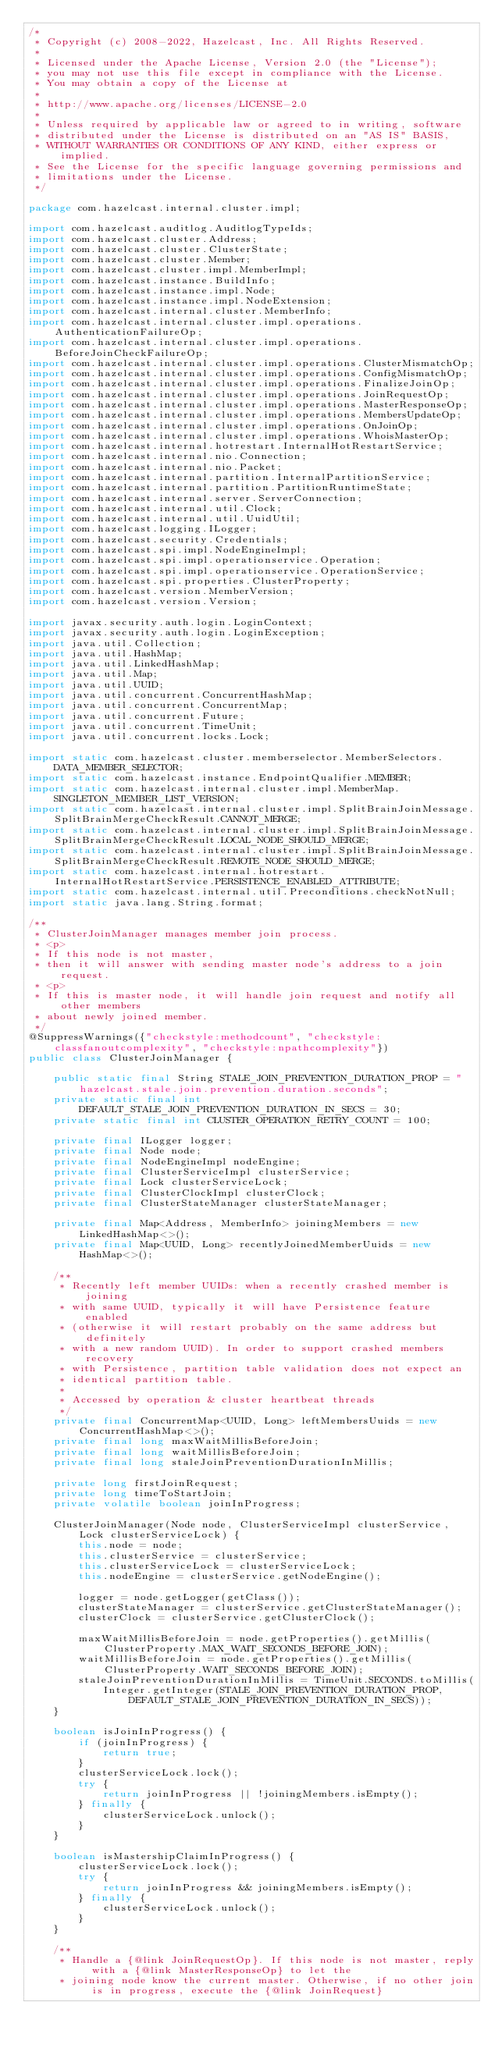Convert code to text. <code><loc_0><loc_0><loc_500><loc_500><_Java_>/*
 * Copyright (c) 2008-2022, Hazelcast, Inc. All Rights Reserved.
 *
 * Licensed under the Apache License, Version 2.0 (the "License");
 * you may not use this file except in compliance with the License.
 * You may obtain a copy of the License at
 *
 * http://www.apache.org/licenses/LICENSE-2.0
 *
 * Unless required by applicable law or agreed to in writing, software
 * distributed under the License is distributed on an "AS IS" BASIS,
 * WITHOUT WARRANTIES OR CONDITIONS OF ANY KIND, either express or implied.
 * See the License for the specific language governing permissions and
 * limitations under the License.
 */

package com.hazelcast.internal.cluster.impl;

import com.hazelcast.auditlog.AuditlogTypeIds;
import com.hazelcast.cluster.Address;
import com.hazelcast.cluster.ClusterState;
import com.hazelcast.cluster.Member;
import com.hazelcast.cluster.impl.MemberImpl;
import com.hazelcast.instance.BuildInfo;
import com.hazelcast.instance.impl.Node;
import com.hazelcast.instance.impl.NodeExtension;
import com.hazelcast.internal.cluster.MemberInfo;
import com.hazelcast.internal.cluster.impl.operations.AuthenticationFailureOp;
import com.hazelcast.internal.cluster.impl.operations.BeforeJoinCheckFailureOp;
import com.hazelcast.internal.cluster.impl.operations.ClusterMismatchOp;
import com.hazelcast.internal.cluster.impl.operations.ConfigMismatchOp;
import com.hazelcast.internal.cluster.impl.operations.FinalizeJoinOp;
import com.hazelcast.internal.cluster.impl.operations.JoinRequestOp;
import com.hazelcast.internal.cluster.impl.operations.MasterResponseOp;
import com.hazelcast.internal.cluster.impl.operations.MembersUpdateOp;
import com.hazelcast.internal.cluster.impl.operations.OnJoinOp;
import com.hazelcast.internal.cluster.impl.operations.WhoisMasterOp;
import com.hazelcast.internal.hotrestart.InternalHotRestartService;
import com.hazelcast.internal.nio.Connection;
import com.hazelcast.internal.nio.Packet;
import com.hazelcast.internal.partition.InternalPartitionService;
import com.hazelcast.internal.partition.PartitionRuntimeState;
import com.hazelcast.internal.server.ServerConnection;
import com.hazelcast.internal.util.Clock;
import com.hazelcast.internal.util.UuidUtil;
import com.hazelcast.logging.ILogger;
import com.hazelcast.security.Credentials;
import com.hazelcast.spi.impl.NodeEngineImpl;
import com.hazelcast.spi.impl.operationservice.Operation;
import com.hazelcast.spi.impl.operationservice.OperationService;
import com.hazelcast.spi.properties.ClusterProperty;
import com.hazelcast.version.MemberVersion;
import com.hazelcast.version.Version;

import javax.security.auth.login.LoginContext;
import javax.security.auth.login.LoginException;
import java.util.Collection;
import java.util.HashMap;
import java.util.LinkedHashMap;
import java.util.Map;
import java.util.UUID;
import java.util.concurrent.ConcurrentHashMap;
import java.util.concurrent.ConcurrentMap;
import java.util.concurrent.Future;
import java.util.concurrent.TimeUnit;
import java.util.concurrent.locks.Lock;

import static com.hazelcast.cluster.memberselector.MemberSelectors.DATA_MEMBER_SELECTOR;
import static com.hazelcast.instance.EndpointQualifier.MEMBER;
import static com.hazelcast.internal.cluster.impl.MemberMap.SINGLETON_MEMBER_LIST_VERSION;
import static com.hazelcast.internal.cluster.impl.SplitBrainJoinMessage.SplitBrainMergeCheckResult.CANNOT_MERGE;
import static com.hazelcast.internal.cluster.impl.SplitBrainJoinMessage.SplitBrainMergeCheckResult.LOCAL_NODE_SHOULD_MERGE;
import static com.hazelcast.internal.cluster.impl.SplitBrainJoinMessage.SplitBrainMergeCheckResult.REMOTE_NODE_SHOULD_MERGE;
import static com.hazelcast.internal.hotrestart.InternalHotRestartService.PERSISTENCE_ENABLED_ATTRIBUTE;
import static com.hazelcast.internal.util.Preconditions.checkNotNull;
import static java.lang.String.format;

/**
 * ClusterJoinManager manages member join process.
 * <p>
 * If this node is not master,
 * then it will answer with sending master node's address to a join request.
 * <p>
 * If this is master node, it will handle join request and notify all other members
 * about newly joined member.
 */
@SuppressWarnings({"checkstyle:methodcount", "checkstyle:classfanoutcomplexity", "checkstyle:npathcomplexity"})
public class ClusterJoinManager {

    public static final String STALE_JOIN_PREVENTION_DURATION_PROP = "hazelcast.stale.join.prevention.duration.seconds";
    private static final int DEFAULT_STALE_JOIN_PREVENTION_DURATION_IN_SECS = 30;
    private static final int CLUSTER_OPERATION_RETRY_COUNT = 100;

    private final ILogger logger;
    private final Node node;
    private final NodeEngineImpl nodeEngine;
    private final ClusterServiceImpl clusterService;
    private final Lock clusterServiceLock;
    private final ClusterClockImpl clusterClock;
    private final ClusterStateManager clusterStateManager;

    private final Map<Address, MemberInfo> joiningMembers = new LinkedHashMap<>();
    private final Map<UUID, Long> recentlyJoinedMemberUuids = new HashMap<>();

    /**
     * Recently left member UUIDs: when a recently crashed member is joining
     * with same UUID, typically it will have Persistence feature enabled
     * (otherwise it will restart probably on the same address but definitely
     * with a new random UUID). In order to support crashed members recovery
     * with Persistence, partition table validation does not expect an
     * identical partition table.
     *
     * Accessed by operation & cluster heartbeat threads
     */
    private final ConcurrentMap<UUID, Long> leftMembersUuids = new ConcurrentHashMap<>();
    private final long maxWaitMillisBeforeJoin;
    private final long waitMillisBeforeJoin;
    private final long staleJoinPreventionDurationInMillis;

    private long firstJoinRequest;
    private long timeToStartJoin;
    private volatile boolean joinInProgress;

    ClusterJoinManager(Node node, ClusterServiceImpl clusterService, Lock clusterServiceLock) {
        this.node = node;
        this.clusterService = clusterService;
        this.clusterServiceLock = clusterServiceLock;
        this.nodeEngine = clusterService.getNodeEngine();

        logger = node.getLogger(getClass());
        clusterStateManager = clusterService.getClusterStateManager();
        clusterClock = clusterService.getClusterClock();

        maxWaitMillisBeforeJoin = node.getProperties().getMillis(ClusterProperty.MAX_WAIT_SECONDS_BEFORE_JOIN);
        waitMillisBeforeJoin = node.getProperties().getMillis(ClusterProperty.WAIT_SECONDS_BEFORE_JOIN);
        staleJoinPreventionDurationInMillis = TimeUnit.SECONDS.toMillis(
            Integer.getInteger(STALE_JOIN_PREVENTION_DURATION_PROP, DEFAULT_STALE_JOIN_PREVENTION_DURATION_IN_SECS));
    }

    boolean isJoinInProgress() {
        if (joinInProgress) {
            return true;
        }
        clusterServiceLock.lock();
        try {
            return joinInProgress || !joiningMembers.isEmpty();
        } finally {
            clusterServiceLock.unlock();
        }
    }

    boolean isMastershipClaimInProgress() {
        clusterServiceLock.lock();
        try {
            return joinInProgress && joiningMembers.isEmpty();
        } finally {
            clusterServiceLock.unlock();
        }
    }

    /**
     * Handle a {@link JoinRequestOp}. If this node is not master, reply with a {@link MasterResponseOp} to let the
     * joining node know the current master. Otherwise, if no other join is in progress, execute the {@link JoinRequest}</code> 